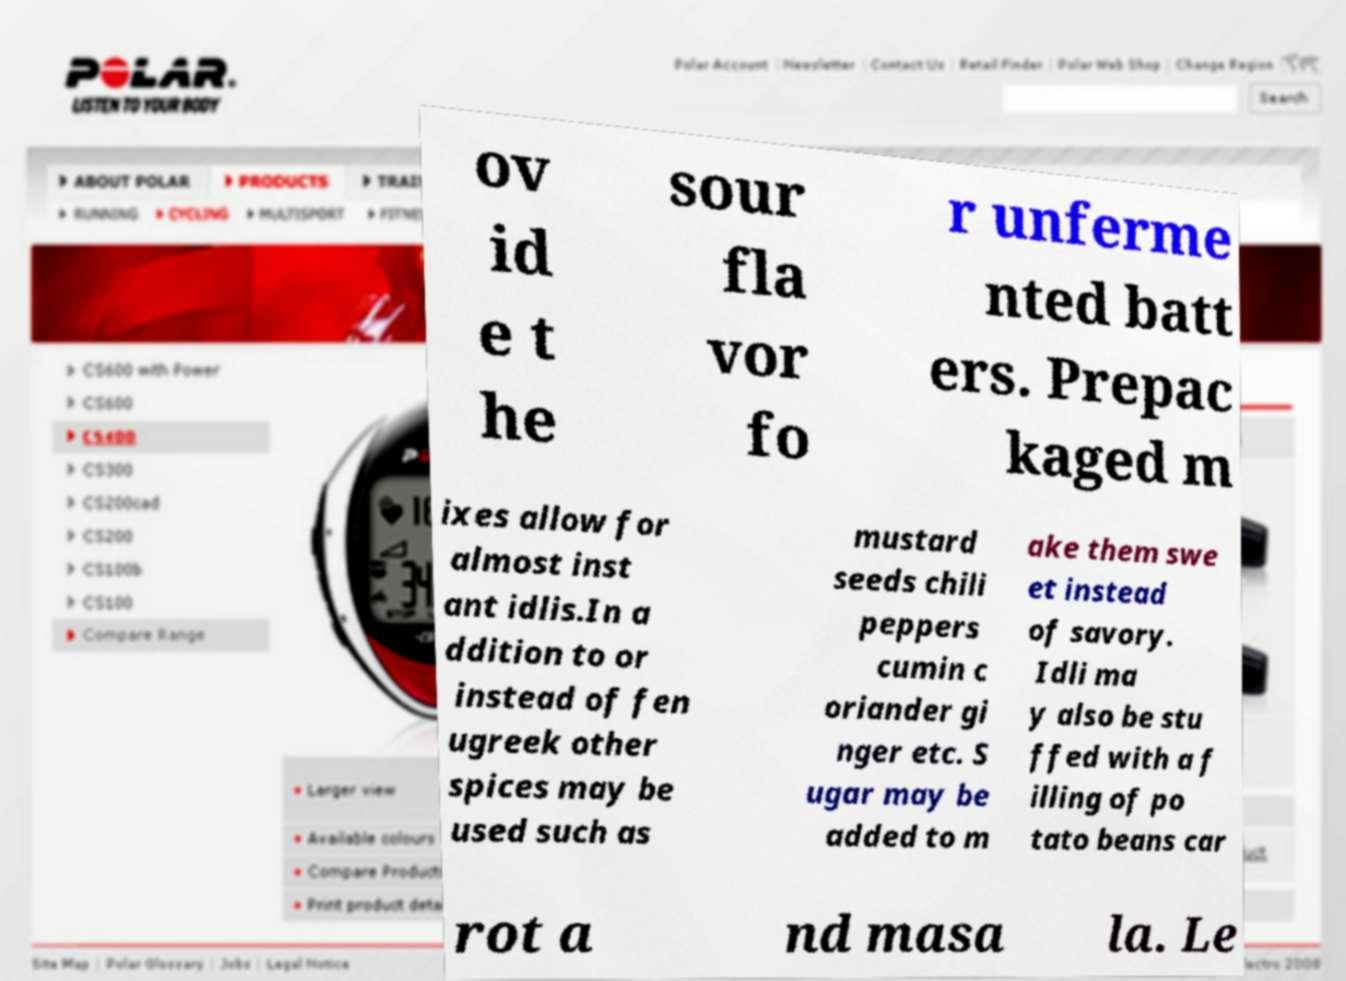Please read and relay the text visible in this image. What does it say? ov id e t he sour fla vor fo r unferme nted batt ers. Prepac kaged m ixes allow for almost inst ant idlis.In a ddition to or instead of fen ugreek other spices may be used such as mustard seeds chili peppers cumin c oriander gi nger etc. S ugar may be added to m ake them swe et instead of savory. Idli ma y also be stu ffed with a f illing of po tato beans car rot a nd masa la. Le 